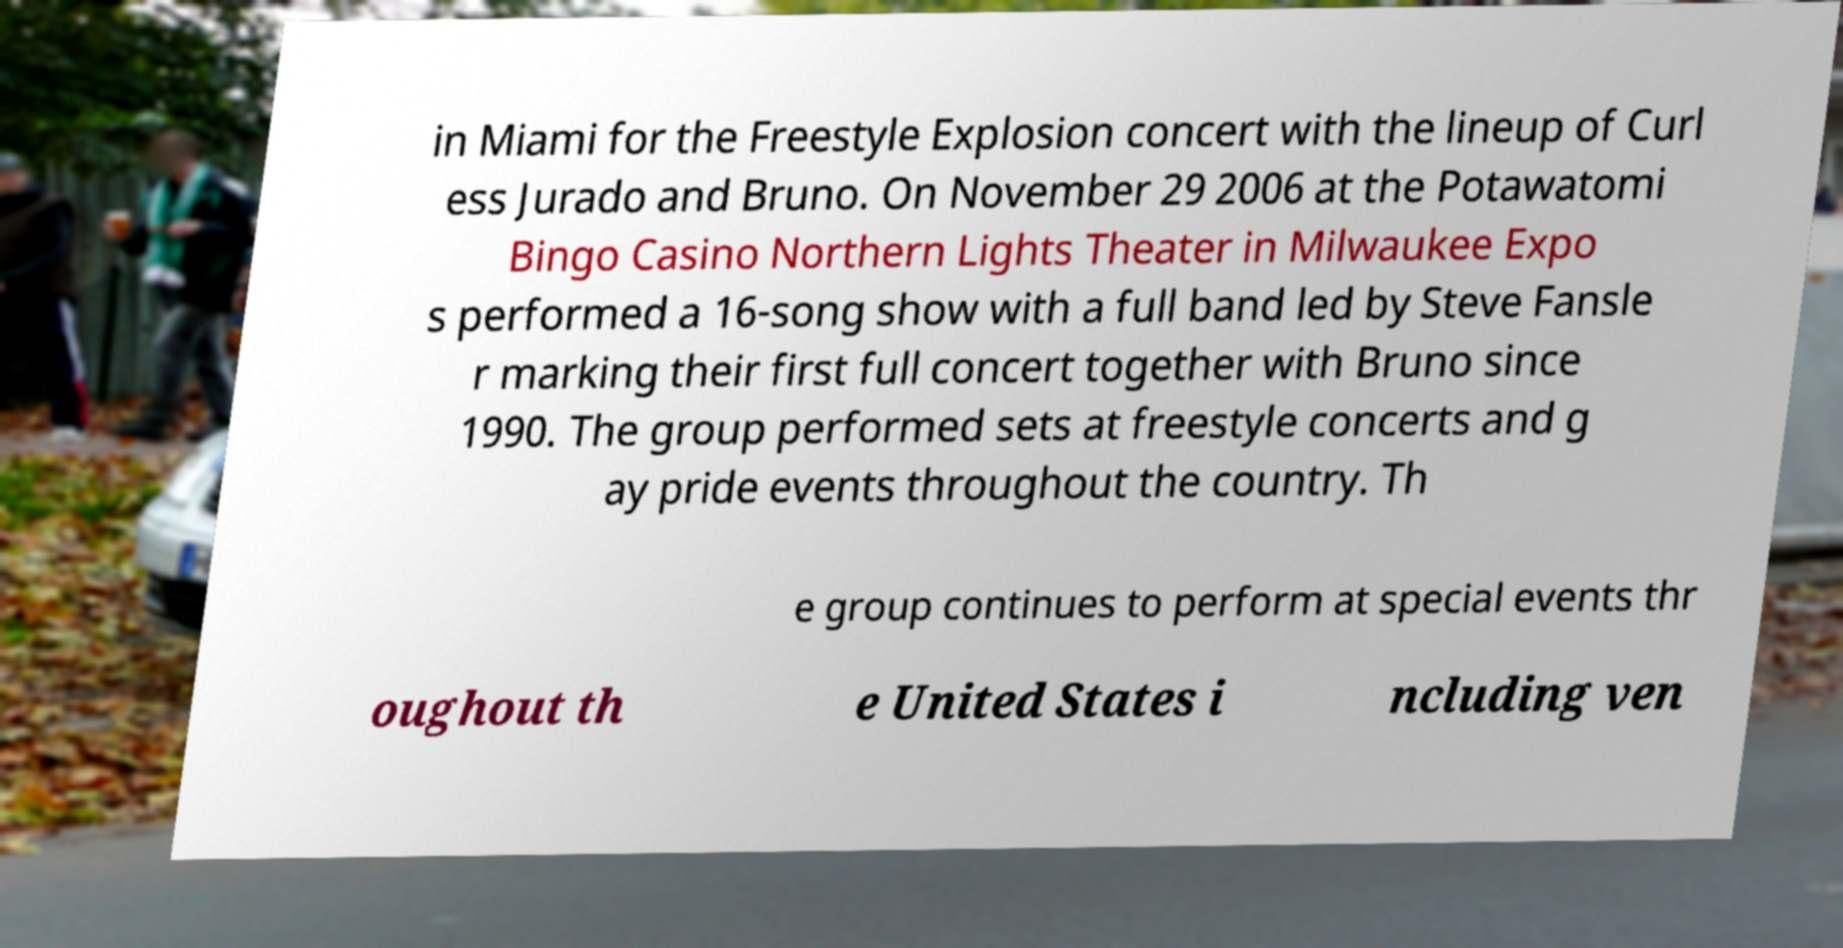Could you extract and type out the text from this image? in Miami for the Freestyle Explosion concert with the lineup of Curl ess Jurado and Bruno. On November 29 2006 at the Potawatomi Bingo Casino Northern Lights Theater in Milwaukee Expo s performed a 16-song show with a full band led by Steve Fansle r marking their first full concert together with Bruno since 1990. The group performed sets at freestyle concerts and g ay pride events throughout the country. Th e group continues to perform at special events thr oughout th e United States i ncluding ven 